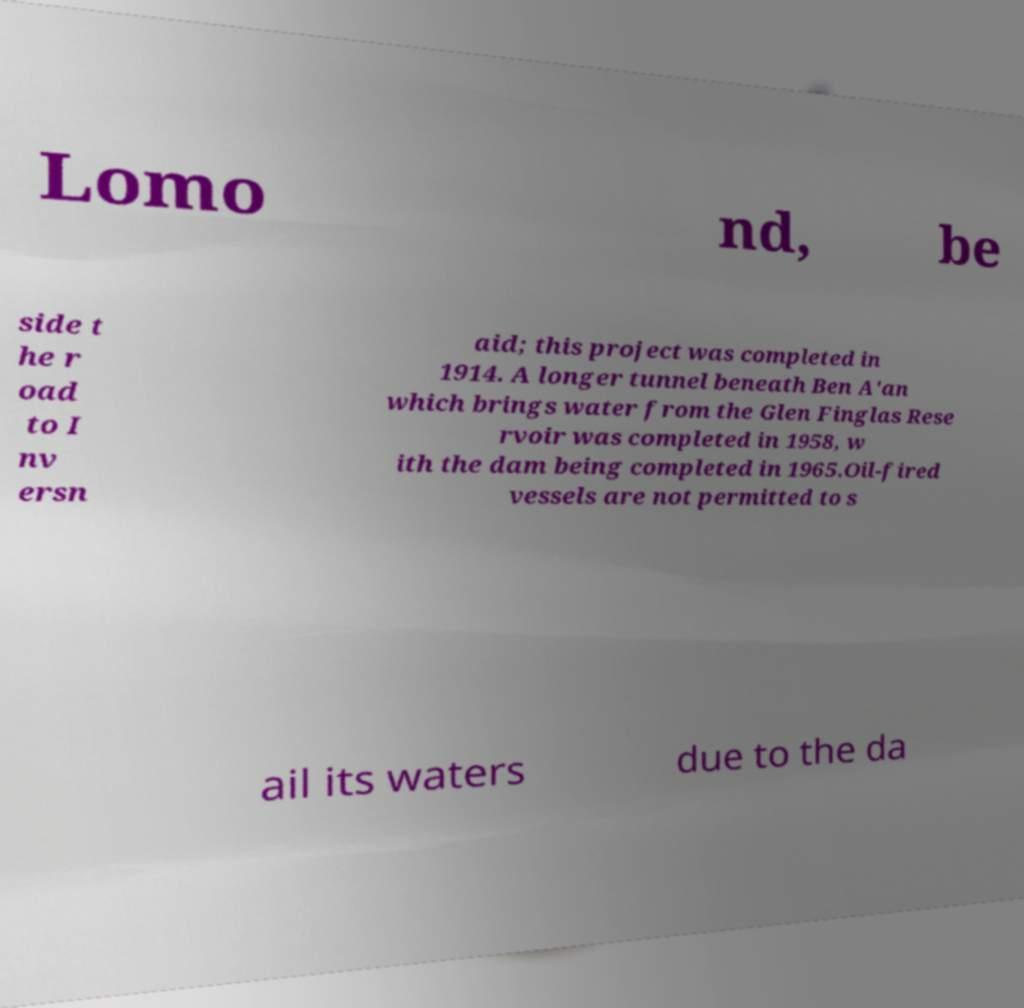There's text embedded in this image that I need extracted. Can you transcribe it verbatim? Lomo nd, be side t he r oad to I nv ersn aid; this project was completed in 1914. A longer tunnel beneath Ben A'an which brings water from the Glen Finglas Rese rvoir was completed in 1958, w ith the dam being completed in 1965.Oil-fired vessels are not permitted to s ail its waters due to the da 